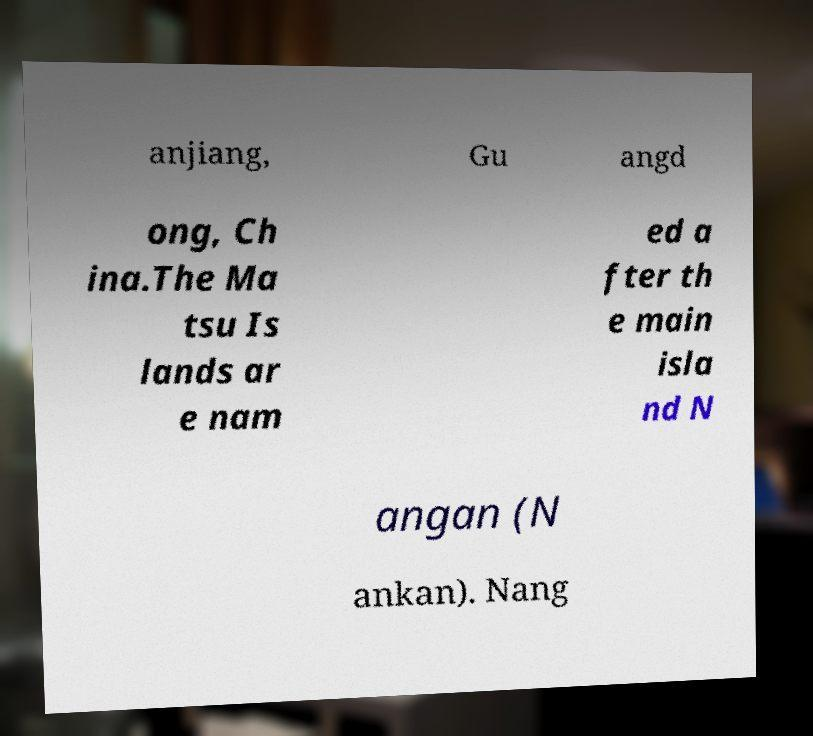What messages or text are displayed in this image? I need them in a readable, typed format. anjiang, Gu angd ong, Ch ina.The Ma tsu Is lands ar e nam ed a fter th e main isla nd N angan (N ankan). Nang 